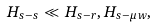<formula> <loc_0><loc_0><loc_500><loc_500>H _ { s - s } \ll H _ { s - r } , H _ { s - \mu w } ,</formula> 